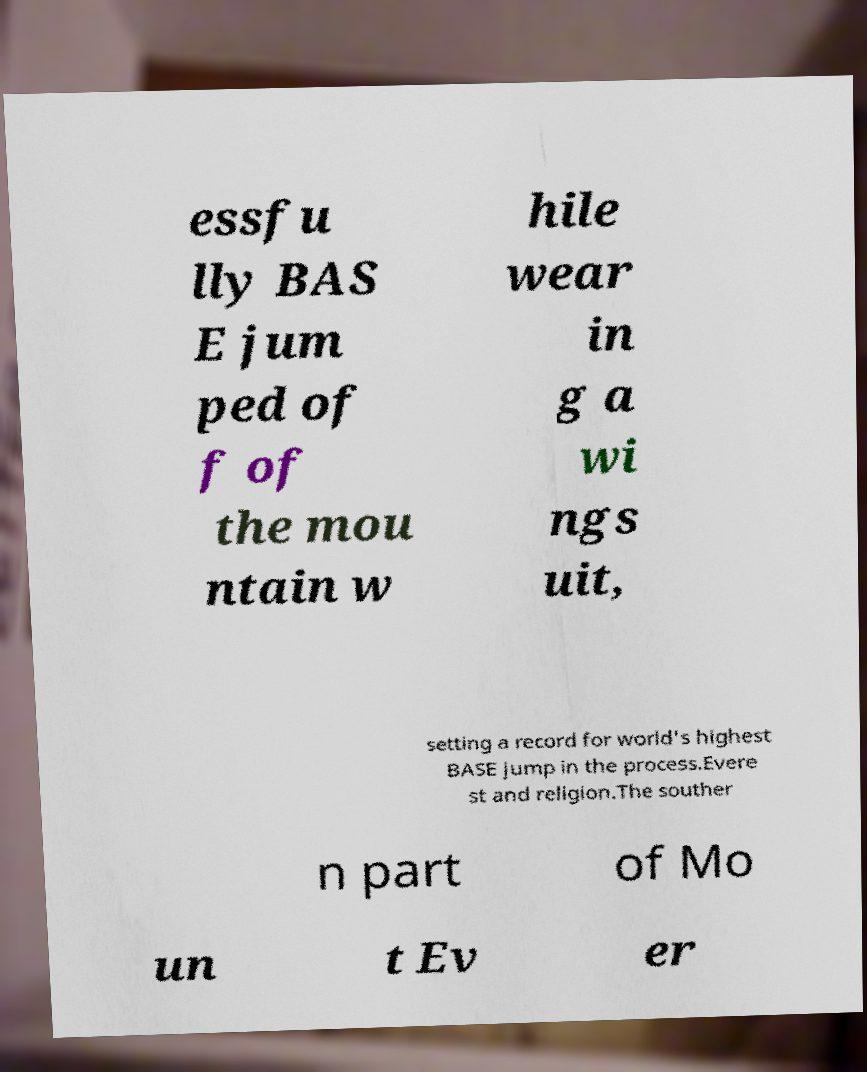Could you assist in decoding the text presented in this image and type it out clearly? essfu lly BAS E jum ped of f of the mou ntain w hile wear in g a wi ngs uit, setting a record for world's highest BASE jump in the process.Evere st and religion.The souther n part of Mo un t Ev er 